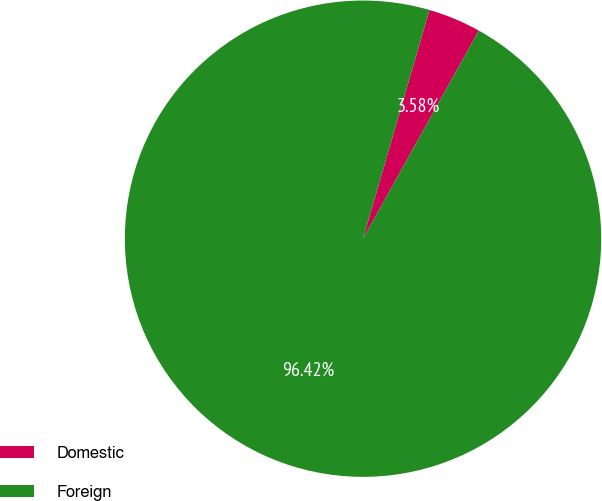Convert chart to OTSL. <chart><loc_0><loc_0><loc_500><loc_500><pie_chart><fcel>Domestic<fcel>Foreign<nl><fcel>3.58%<fcel>96.42%<nl></chart> 